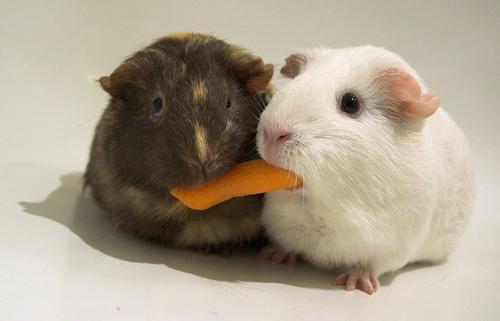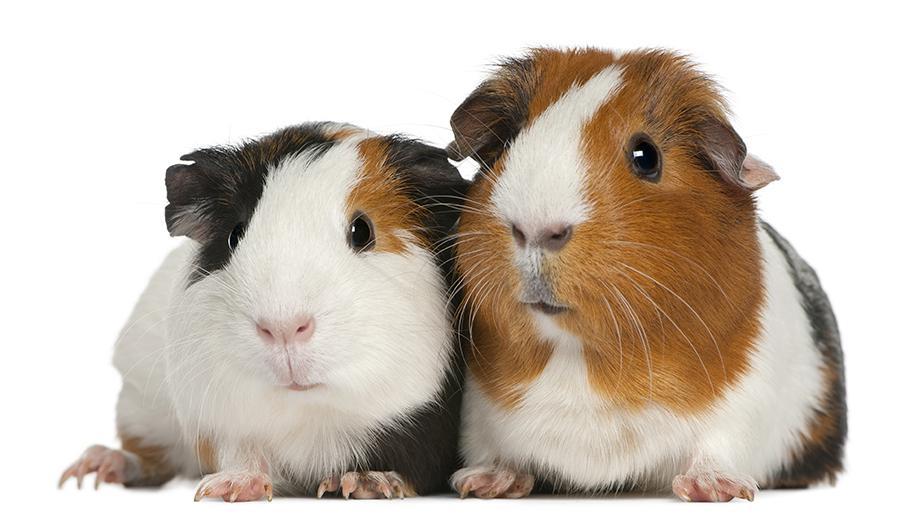The first image is the image on the left, the second image is the image on the right. For the images displayed, is the sentence "There are  4 guinea pigs in the pair" factually correct? Answer yes or no. Yes. 